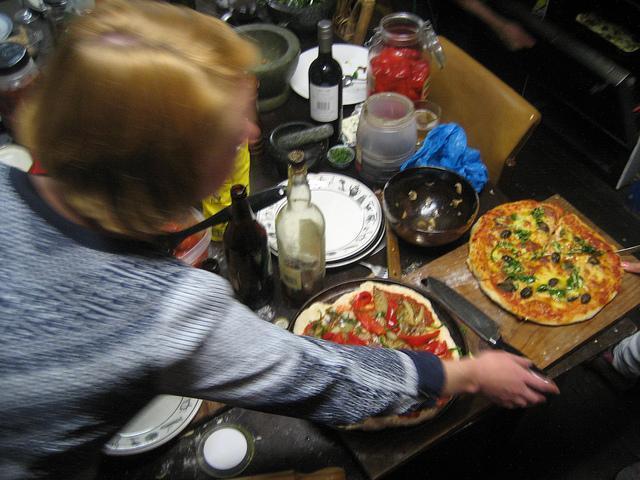How many pizzas are on the table?
Give a very brief answer. 2. How many pizzas can you see?
Give a very brief answer. 2. How many bowls can you see?
Give a very brief answer. 2. How many bottles can you see?
Give a very brief answer. 3. 